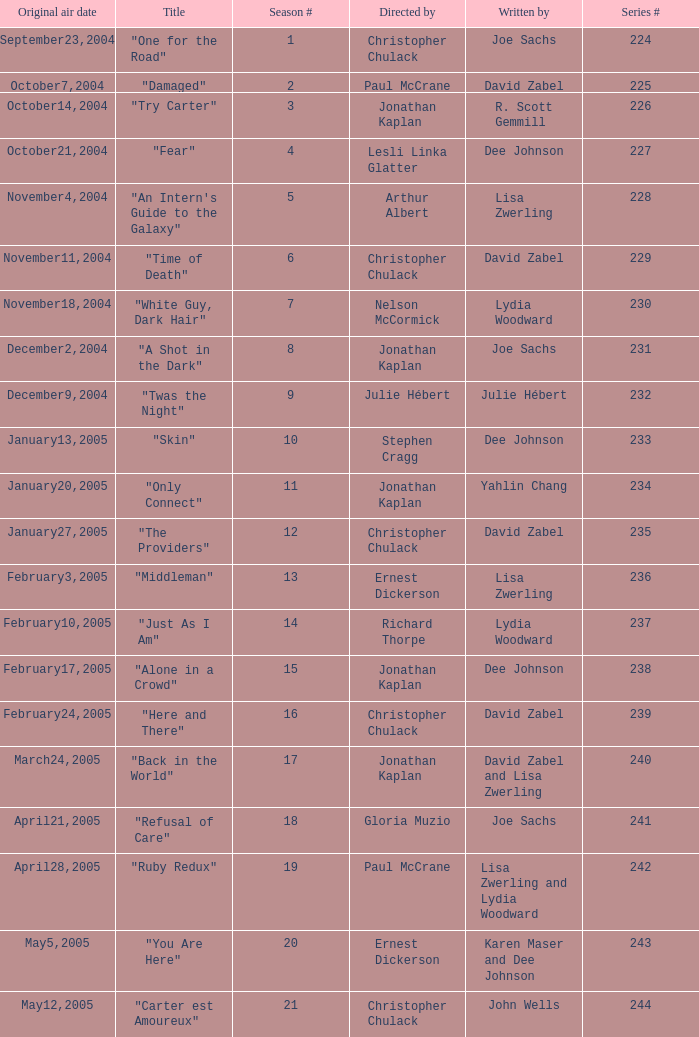Name who wrote the episode directed by arthur albert Lisa Zwerling. 